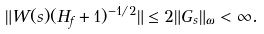Convert formula to latex. <formula><loc_0><loc_0><loc_500><loc_500>\| W ( s ) ( H _ { f } + 1 ) ^ { - 1 / 2 } \| \leq 2 \| G _ { s } \| _ { \omega } < \infty .</formula> 